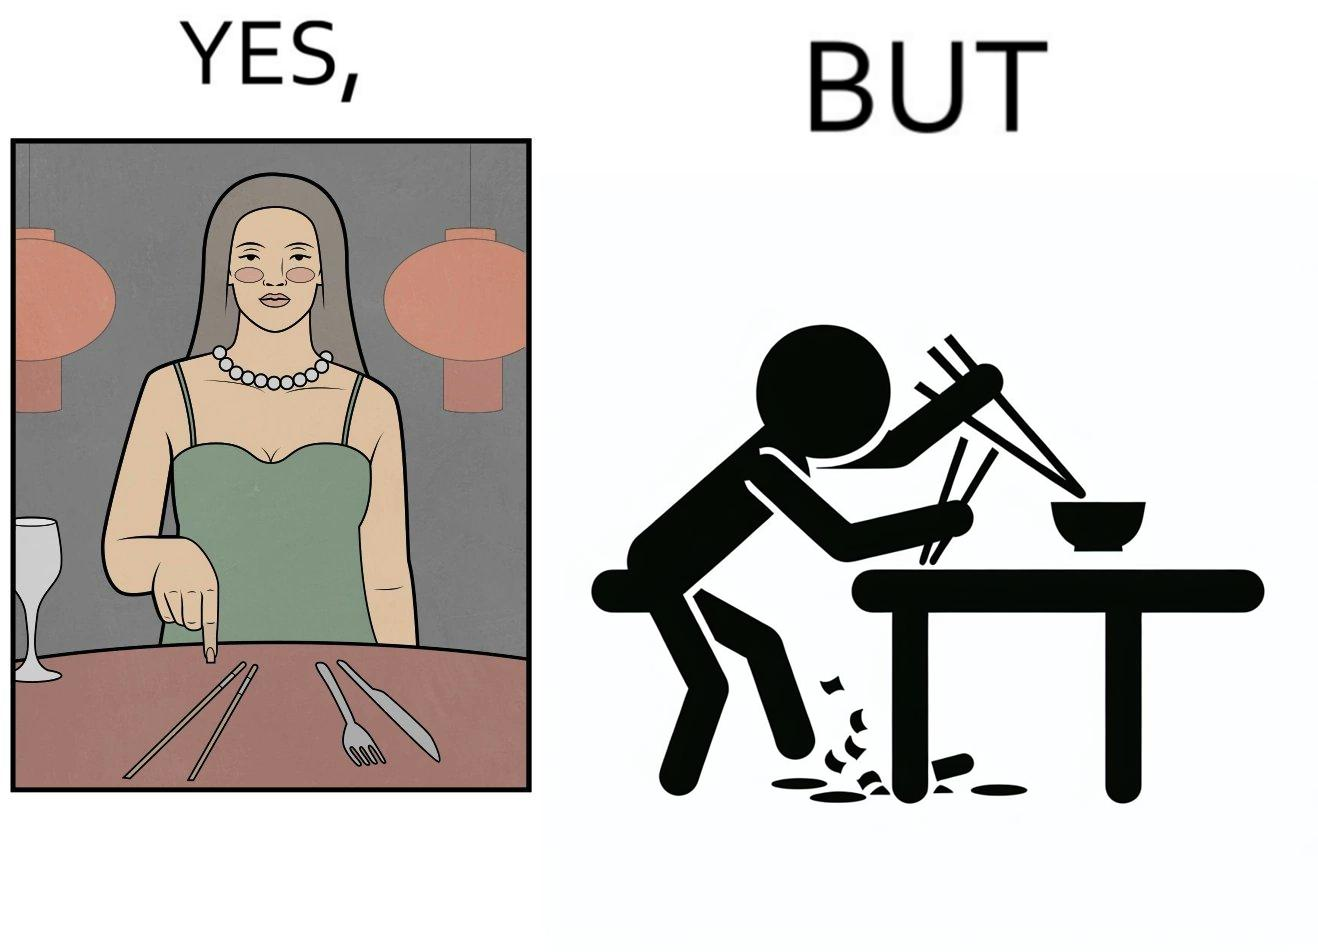What is shown in the left half versus the right half of this image? In the left part of the image: The image shows a woman sitting at a table in a restaruant pointing to chopsticks on her table. There is also a wine glass, a fork and a knief on her table. In the right part of the image: The image shows a person using chopstick to pick up food from the cup. The person is not able to handle food with chopstick well and is dropping the food around the cup on the table. 